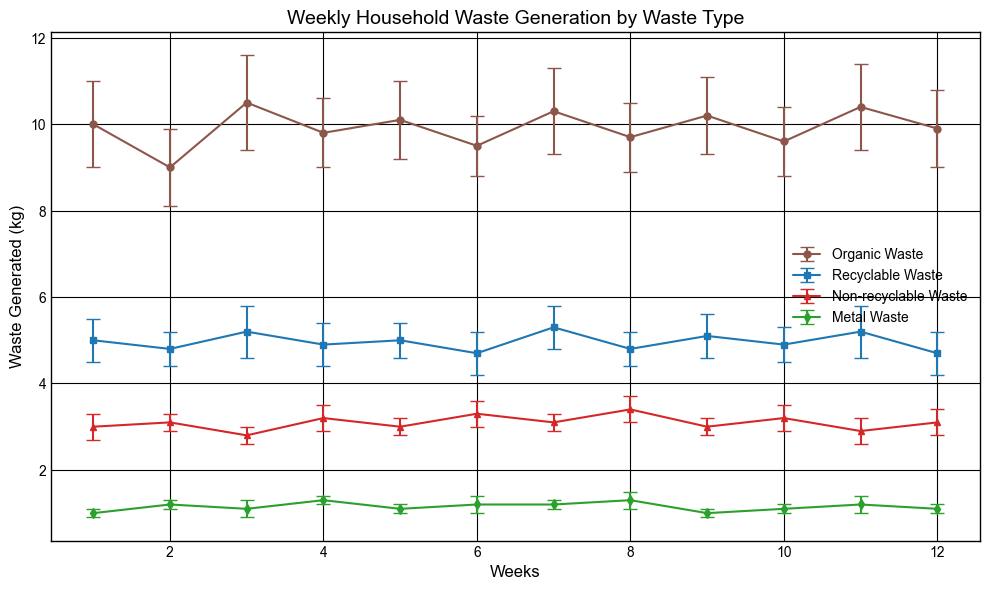Which week had the highest amount of organic waste generated? By looking at the plot, the height of the marker for Organic Waste is highest in week 3, which has 10.5 kg.
Answer: Week 3 Between weeks 4 and 10, which one had more recyclable waste generated? By comparing the heights of the markers for Recyclable Waste, week 4 had 4.9 kg and week 10 had 4.9 kg. They are equal in these two weeks.
Answer: Equal Which type of waste had the smallest error bar across all weeks? By examining the length of the error bars on the plot, Metal Waste has the smallest error bars throughout the weeks, all around 0.1-0.2 kg.
Answer: Metal Waste How does the amount of non-recyclable waste in week 2 compare to week 8? In the plot, Non-recyclable Waste is 3.1 kg in week 2 and 3.4 kg in week 8. Week 8 has a higher value.
Answer: Week 8 has more What is the average amount of recyclable waste generated over weeks 1 to 5? The sum of Recyclable Waste for weeks 1 to 5 is 5 + 4.8 + 5.2 + 4.9 + 5 = 24.9 kg. The average is 24.9 kg / 5 = 4.98 kg.
Answer: 4.98 kg Which type of waste fluctuates the most over the 12 weeks? By observing the variance in the heights of the markers and the length of the error bars on each type of waste, Organic Waste shows the most fluctuation, with values ranging from 9 to 10.5 kg and larger error bars.
Answer: Organic Waste Is the amount of metal waste consistently higher or lower than 1 kg? By observing the markers for Metal Waste, each week's generated Metal Waste is between 1 to 1.3 kg, consistently higher than 1 kg.
Answer: Higher What is the total waste generated (sum of all types) in week 6? Sum up all types of waste in week 6: Organic (9.5 kg) + Recyclable (4.7 kg) + Non-recyclable (3.3 kg) + Metal (1.2 kg) = 18.7 kg.
Answer: 18.7 kg Compared to week 7, which week had the most similar amount of organic waste generated? By comparing weeks visually, week 9 had 10.2 kg of Organic Waste, which is closest to week 7's 10.3 kg.
Answer: Week 9 What is the most significant difference in waste types between any two consecutive weeks? First calculate differences for each type between consecutive weeks: 
For example, Organic Waste Week 1 to 2: 10 - 9 = 1; Recyclable Week 1 to 2: 5 - 4.8 = 0.2, etc. The most significant difference appears in Metal Waste between week 8 and week 9, where it changes from 1.3 kg to 1 kg, a difference of 0.3 kg.
Answer: Metal Waste between weeks 8 and 9 